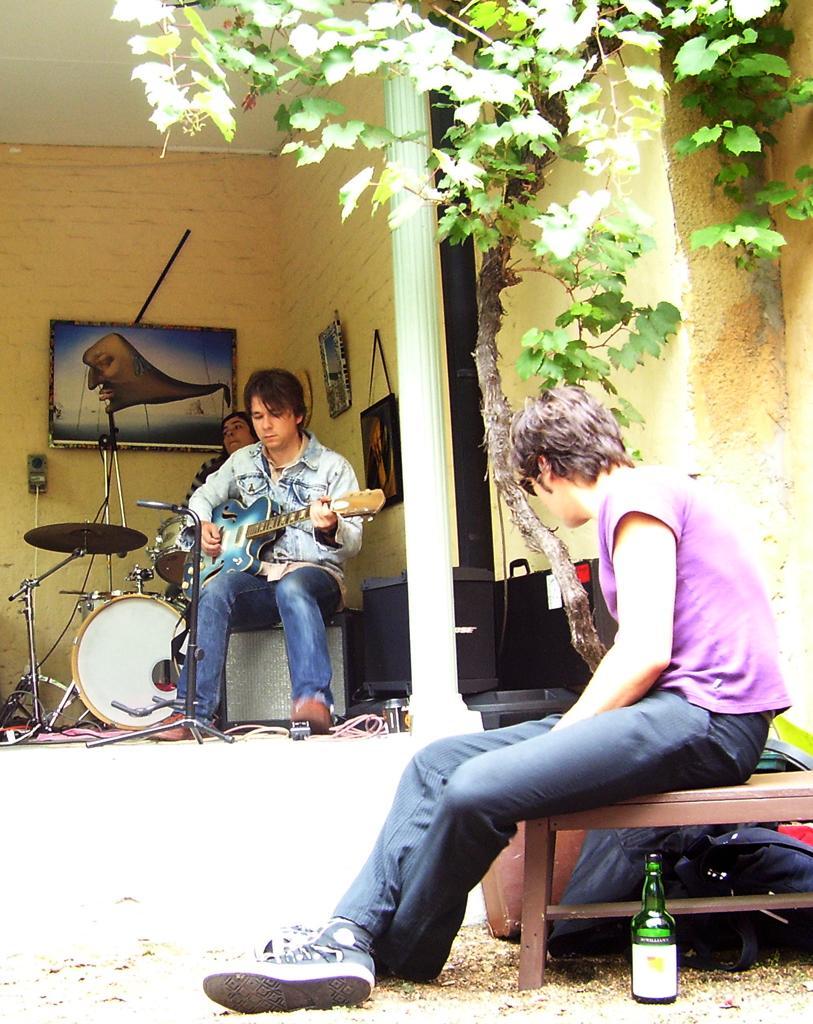How would you summarize this image in a sentence or two? In this picture, In the right side there is a boy sitting on the brown color table, There is a wine bottle which is in green color, In the background there is a man sitting and holding a music instrument and there are some music instruments, There is a green color plant and in the background there is a yellow color wall on that wall there is a picture which is in black color. 